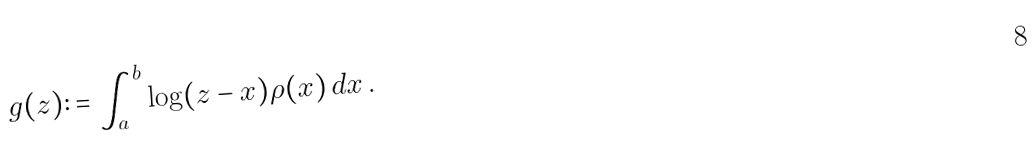<formula> <loc_0><loc_0><loc_500><loc_500>g ( z ) \colon = \int _ { a } ^ { b } \log ( z - x ) \rho ( x ) \, d x \, .</formula> 